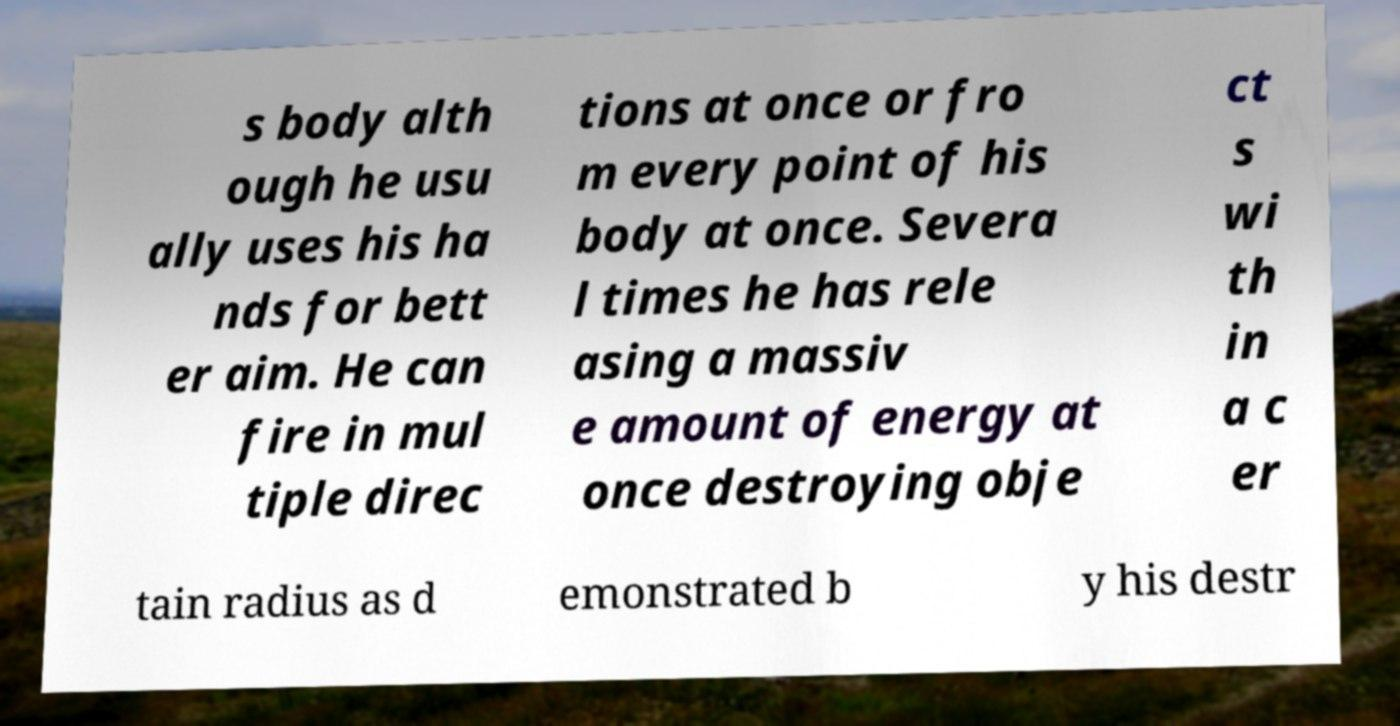Can you read and provide the text displayed in the image?This photo seems to have some interesting text. Can you extract and type it out for me? s body alth ough he usu ally uses his ha nds for bett er aim. He can fire in mul tiple direc tions at once or fro m every point of his body at once. Severa l times he has rele asing a massiv e amount of energy at once destroying obje ct s wi th in a c er tain radius as d emonstrated b y his destr 